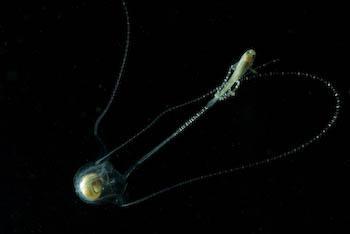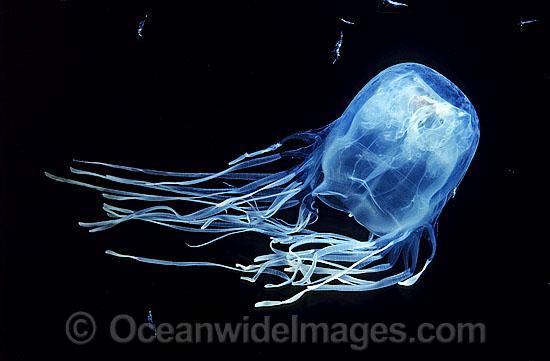The first image is the image on the left, the second image is the image on the right. For the images shown, is this caption "One of the images shows a single fish being pulled in on the tentacles of a lone jellyfish" true? Answer yes or no. Yes. 